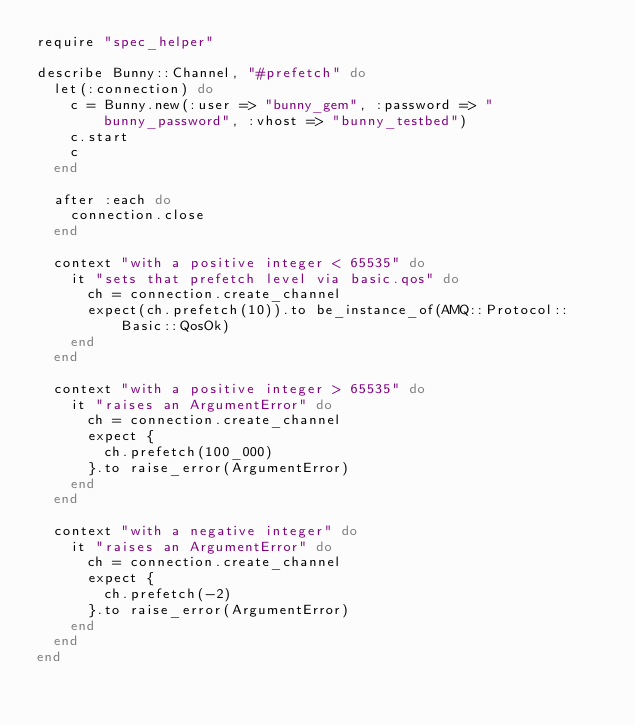<code> <loc_0><loc_0><loc_500><loc_500><_Ruby_>require "spec_helper"

describe Bunny::Channel, "#prefetch" do
  let(:connection) do
    c = Bunny.new(:user => "bunny_gem", :password => "bunny_password", :vhost => "bunny_testbed")
    c.start
    c
  end

  after :each do
    connection.close
  end

  context "with a positive integer < 65535" do
    it "sets that prefetch level via basic.qos" do
      ch = connection.create_channel
      expect(ch.prefetch(10)).to be_instance_of(AMQ::Protocol::Basic::QosOk)
    end
  end

  context "with a positive integer > 65535" do
    it "raises an ArgumentError" do
      ch = connection.create_channel
      expect {
        ch.prefetch(100_000)
      }.to raise_error(ArgumentError)
    end
  end

  context "with a negative integer" do
    it "raises an ArgumentError" do
      ch = connection.create_channel
      expect {
        ch.prefetch(-2)
      }.to raise_error(ArgumentError)
    end
  end
end
</code> 